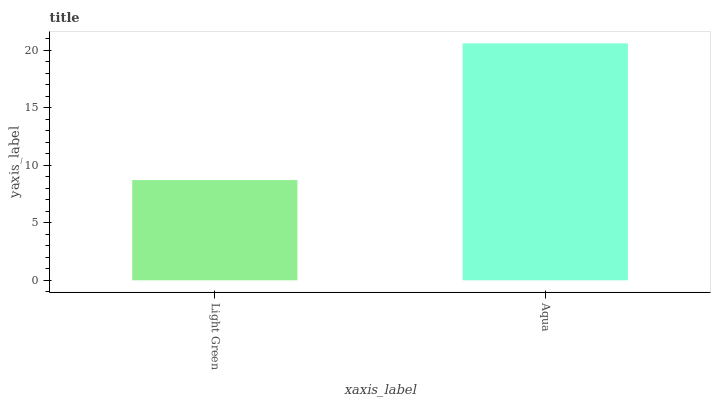Is Aqua the minimum?
Answer yes or no. No. Is Aqua greater than Light Green?
Answer yes or no. Yes. Is Light Green less than Aqua?
Answer yes or no. Yes. Is Light Green greater than Aqua?
Answer yes or no. No. Is Aqua less than Light Green?
Answer yes or no. No. Is Aqua the high median?
Answer yes or no. Yes. Is Light Green the low median?
Answer yes or no. Yes. Is Light Green the high median?
Answer yes or no. No. Is Aqua the low median?
Answer yes or no. No. 